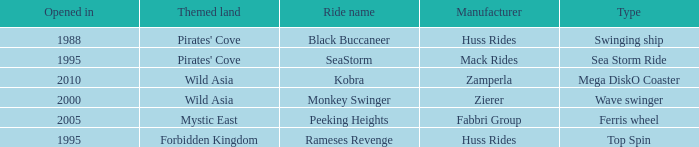What ride was manufactured by Zierer? Monkey Swinger. 